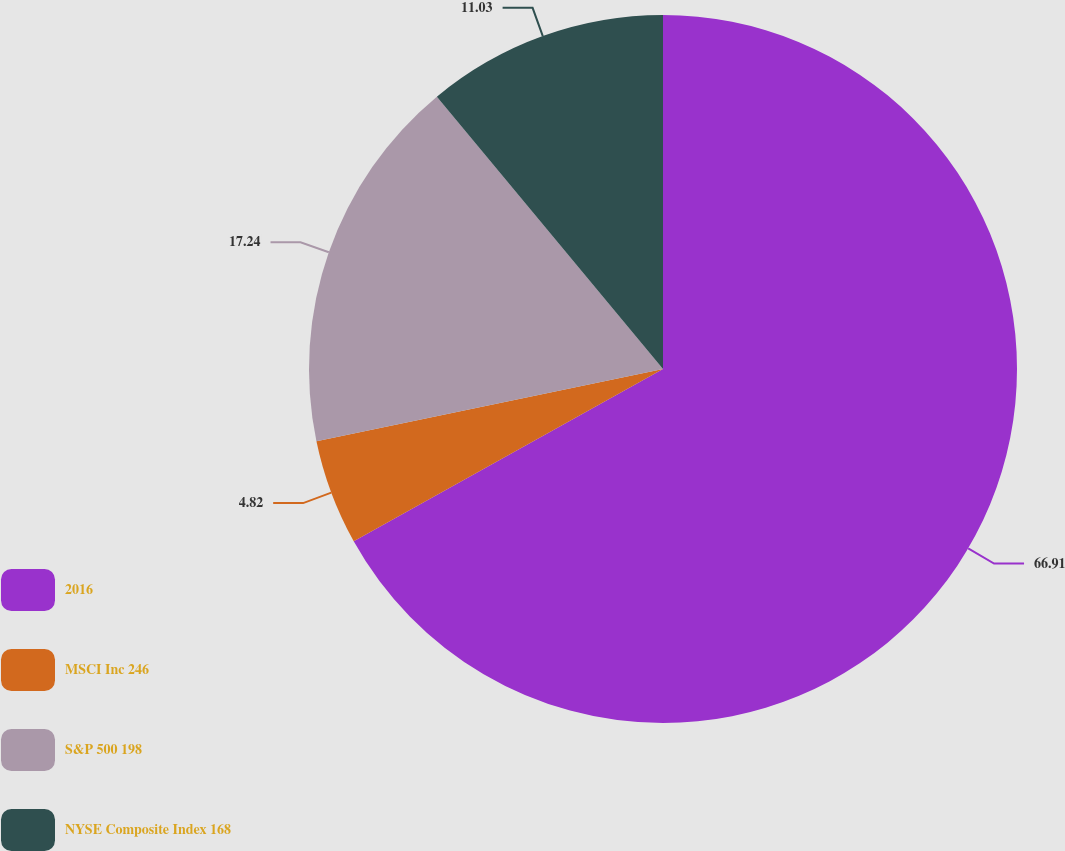Convert chart. <chart><loc_0><loc_0><loc_500><loc_500><pie_chart><fcel>2016<fcel>MSCI Inc 246<fcel>S&P 500 198<fcel>NYSE Composite Index 168<nl><fcel>66.92%<fcel>4.82%<fcel>17.24%<fcel>11.03%<nl></chart> 